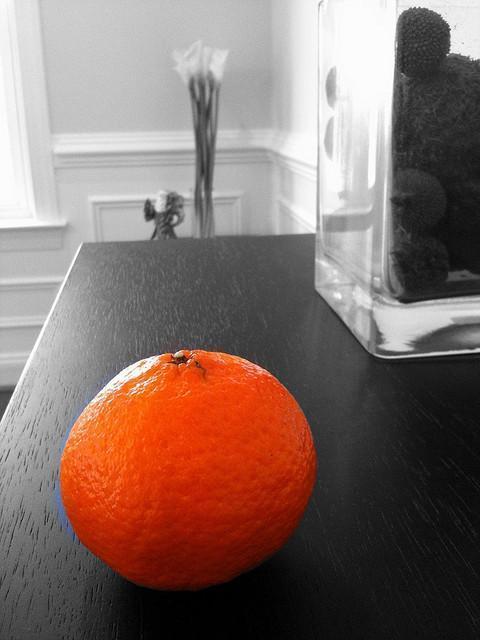Is the given caption "The orange is touching the dining table." fitting for the image?
Answer yes or no. Yes. 